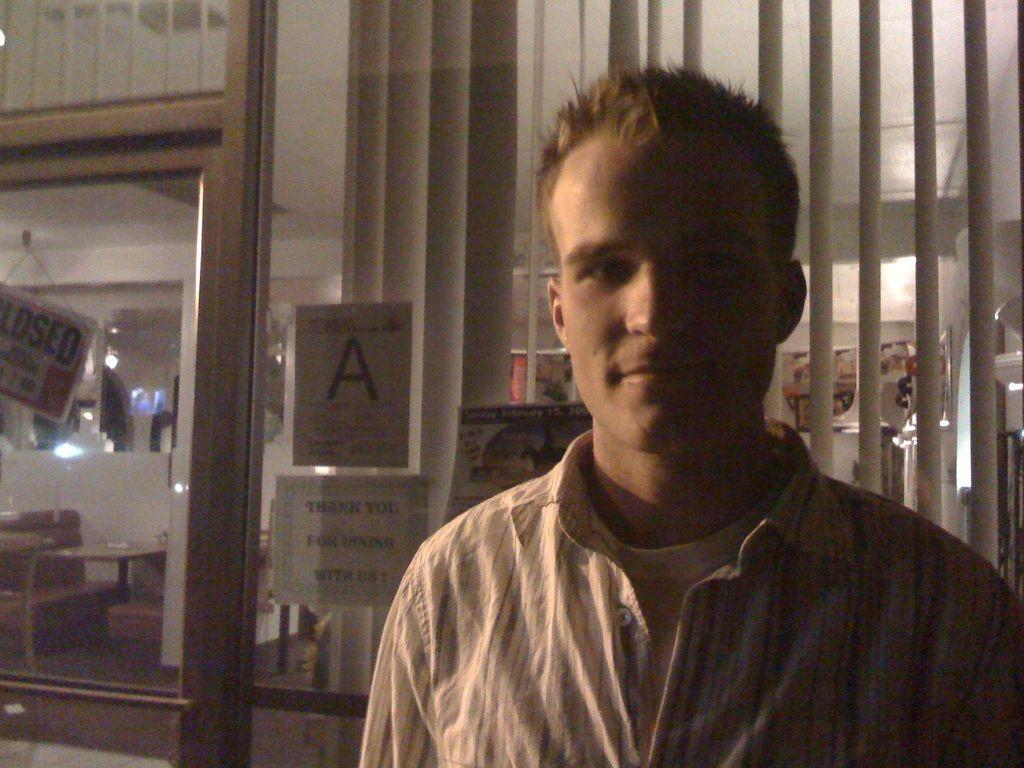Who or what is the main subject in the center of the image? There is a person in the center of the image. What can be seen in the background of the image? There is a glass window in the background of the image. Is there any window treatment present in the image? Yes, there is a curtain associated with the glass window. What type of insect can be seen crawling on the plantation in the image? There is no insect or plantation present in the image; it features a person and a glass window with a curtain. 